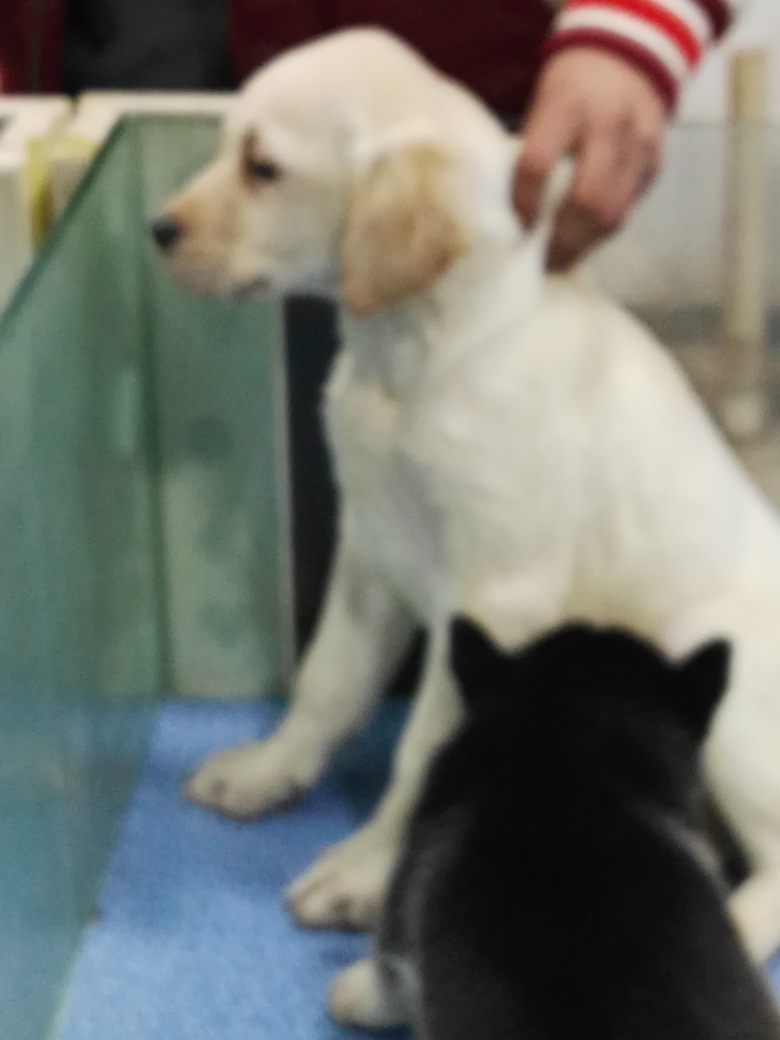What can you tell about the person in the image? There is a person partially visible in the image, seen only by their arm and hand. The person is wearing a red and white sleeve indicative of a sweater or sports jacket. While not much can be discerned about their identity, it seems like they are interacting with or petting the white dog, perhaps providing comfort or keeping the dog steady. 